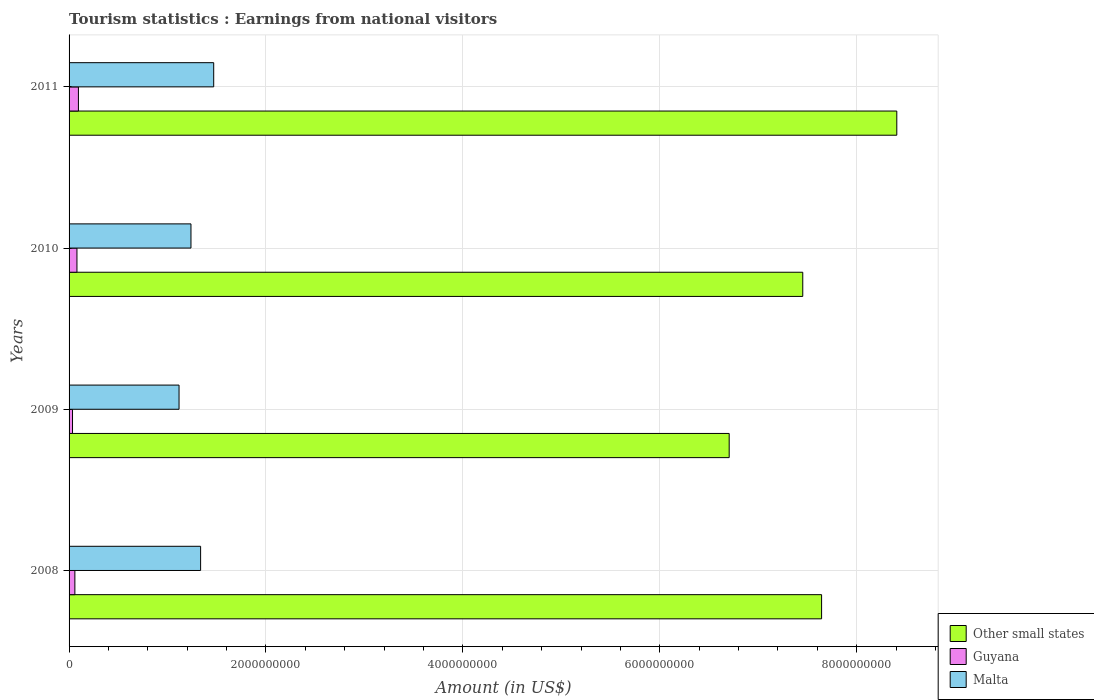How many different coloured bars are there?
Ensure brevity in your answer.  3. How many groups of bars are there?
Your answer should be very brief. 4. In how many cases, is the number of bars for a given year not equal to the number of legend labels?
Your answer should be very brief. 0. What is the earnings from national visitors in Other small states in 2009?
Give a very brief answer. 6.70e+09. Across all years, what is the maximum earnings from national visitors in Malta?
Your answer should be very brief. 1.47e+09. Across all years, what is the minimum earnings from national visitors in Malta?
Offer a very short reply. 1.12e+09. In which year was the earnings from national visitors in Malta minimum?
Keep it short and to the point. 2009. What is the total earnings from national visitors in Guyana in the graph?
Your answer should be very brief. 2.69e+08. What is the difference between the earnings from national visitors in Other small states in 2010 and that in 2011?
Ensure brevity in your answer.  -9.55e+08. What is the difference between the earnings from national visitors in Other small states in 2009 and the earnings from national visitors in Guyana in 2008?
Make the answer very short. 6.65e+09. What is the average earnings from national visitors in Malta per year?
Make the answer very short. 1.29e+09. In the year 2009, what is the difference between the earnings from national visitors in Guyana and earnings from national visitors in Malta?
Offer a very short reply. -1.08e+09. What is the ratio of the earnings from national visitors in Guyana in 2010 to that in 2011?
Ensure brevity in your answer.  0.84. Is the earnings from national visitors in Guyana in 2008 less than that in 2009?
Ensure brevity in your answer.  No. What is the difference between the highest and the second highest earnings from national visitors in Other small states?
Provide a short and direct response. 7.64e+08. What is the difference between the highest and the lowest earnings from national visitors in Malta?
Your answer should be compact. 3.52e+08. In how many years, is the earnings from national visitors in Other small states greater than the average earnings from national visitors in Other small states taken over all years?
Make the answer very short. 2. What does the 1st bar from the top in 2011 represents?
Ensure brevity in your answer.  Malta. What does the 2nd bar from the bottom in 2009 represents?
Offer a terse response. Guyana. What is the difference between two consecutive major ticks on the X-axis?
Ensure brevity in your answer.  2.00e+09. Where does the legend appear in the graph?
Keep it short and to the point. Bottom right. How are the legend labels stacked?
Provide a short and direct response. Vertical. What is the title of the graph?
Your response must be concise. Tourism statistics : Earnings from national visitors. What is the label or title of the Y-axis?
Ensure brevity in your answer.  Years. What is the Amount (in US$) in Other small states in 2008?
Give a very brief answer. 7.64e+09. What is the Amount (in US$) of Guyana in 2008?
Your answer should be very brief. 5.90e+07. What is the Amount (in US$) in Malta in 2008?
Ensure brevity in your answer.  1.34e+09. What is the Amount (in US$) in Other small states in 2009?
Offer a terse response. 6.70e+09. What is the Amount (in US$) in Guyana in 2009?
Offer a terse response. 3.50e+07. What is the Amount (in US$) in Malta in 2009?
Make the answer very short. 1.12e+09. What is the Amount (in US$) of Other small states in 2010?
Offer a very short reply. 7.45e+09. What is the Amount (in US$) in Guyana in 2010?
Provide a succinct answer. 8.00e+07. What is the Amount (in US$) of Malta in 2010?
Offer a terse response. 1.24e+09. What is the Amount (in US$) of Other small states in 2011?
Keep it short and to the point. 8.41e+09. What is the Amount (in US$) in Guyana in 2011?
Your answer should be very brief. 9.50e+07. What is the Amount (in US$) in Malta in 2011?
Your answer should be compact. 1.47e+09. Across all years, what is the maximum Amount (in US$) in Other small states?
Your response must be concise. 8.41e+09. Across all years, what is the maximum Amount (in US$) in Guyana?
Ensure brevity in your answer.  9.50e+07. Across all years, what is the maximum Amount (in US$) in Malta?
Keep it short and to the point. 1.47e+09. Across all years, what is the minimum Amount (in US$) in Other small states?
Your answer should be very brief. 6.70e+09. Across all years, what is the minimum Amount (in US$) of Guyana?
Your answer should be compact. 3.50e+07. Across all years, what is the minimum Amount (in US$) of Malta?
Ensure brevity in your answer.  1.12e+09. What is the total Amount (in US$) in Other small states in the graph?
Your response must be concise. 3.02e+1. What is the total Amount (in US$) in Guyana in the graph?
Your response must be concise. 2.69e+08. What is the total Amount (in US$) of Malta in the graph?
Make the answer very short. 5.16e+09. What is the difference between the Amount (in US$) in Other small states in 2008 and that in 2009?
Provide a succinct answer. 9.39e+08. What is the difference between the Amount (in US$) of Guyana in 2008 and that in 2009?
Offer a very short reply. 2.40e+07. What is the difference between the Amount (in US$) in Malta in 2008 and that in 2009?
Ensure brevity in your answer.  2.19e+08. What is the difference between the Amount (in US$) in Other small states in 2008 and that in 2010?
Provide a short and direct response. 1.91e+08. What is the difference between the Amount (in US$) of Guyana in 2008 and that in 2010?
Provide a succinct answer. -2.10e+07. What is the difference between the Amount (in US$) of Malta in 2008 and that in 2010?
Ensure brevity in your answer.  9.80e+07. What is the difference between the Amount (in US$) in Other small states in 2008 and that in 2011?
Your answer should be compact. -7.64e+08. What is the difference between the Amount (in US$) in Guyana in 2008 and that in 2011?
Your answer should be compact. -3.60e+07. What is the difference between the Amount (in US$) of Malta in 2008 and that in 2011?
Give a very brief answer. -1.33e+08. What is the difference between the Amount (in US$) in Other small states in 2009 and that in 2010?
Provide a succinct answer. -7.47e+08. What is the difference between the Amount (in US$) in Guyana in 2009 and that in 2010?
Ensure brevity in your answer.  -4.50e+07. What is the difference between the Amount (in US$) of Malta in 2009 and that in 2010?
Your answer should be compact. -1.21e+08. What is the difference between the Amount (in US$) in Other small states in 2009 and that in 2011?
Offer a very short reply. -1.70e+09. What is the difference between the Amount (in US$) of Guyana in 2009 and that in 2011?
Ensure brevity in your answer.  -6.00e+07. What is the difference between the Amount (in US$) of Malta in 2009 and that in 2011?
Your response must be concise. -3.52e+08. What is the difference between the Amount (in US$) of Other small states in 2010 and that in 2011?
Offer a very short reply. -9.55e+08. What is the difference between the Amount (in US$) of Guyana in 2010 and that in 2011?
Your answer should be very brief. -1.50e+07. What is the difference between the Amount (in US$) of Malta in 2010 and that in 2011?
Keep it short and to the point. -2.31e+08. What is the difference between the Amount (in US$) of Other small states in 2008 and the Amount (in US$) of Guyana in 2009?
Ensure brevity in your answer.  7.61e+09. What is the difference between the Amount (in US$) in Other small states in 2008 and the Amount (in US$) in Malta in 2009?
Give a very brief answer. 6.53e+09. What is the difference between the Amount (in US$) of Guyana in 2008 and the Amount (in US$) of Malta in 2009?
Provide a succinct answer. -1.06e+09. What is the difference between the Amount (in US$) of Other small states in 2008 and the Amount (in US$) of Guyana in 2010?
Your answer should be compact. 7.56e+09. What is the difference between the Amount (in US$) in Other small states in 2008 and the Amount (in US$) in Malta in 2010?
Provide a short and direct response. 6.41e+09. What is the difference between the Amount (in US$) in Guyana in 2008 and the Amount (in US$) in Malta in 2010?
Make the answer very short. -1.18e+09. What is the difference between the Amount (in US$) in Other small states in 2008 and the Amount (in US$) in Guyana in 2011?
Your answer should be very brief. 7.55e+09. What is the difference between the Amount (in US$) of Other small states in 2008 and the Amount (in US$) of Malta in 2011?
Give a very brief answer. 6.17e+09. What is the difference between the Amount (in US$) of Guyana in 2008 and the Amount (in US$) of Malta in 2011?
Provide a short and direct response. -1.41e+09. What is the difference between the Amount (in US$) in Other small states in 2009 and the Amount (in US$) in Guyana in 2010?
Ensure brevity in your answer.  6.62e+09. What is the difference between the Amount (in US$) in Other small states in 2009 and the Amount (in US$) in Malta in 2010?
Keep it short and to the point. 5.47e+09. What is the difference between the Amount (in US$) in Guyana in 2009 and the Amount (in US$) in Malta in 2010?
Your answer should be very brief. -1.20e+09. What is the difference between the Amount (in US$) in Other small states in 2009 and the Amount (in US$) in Guyana in 2011?
Your answer should be very brief. 6.61e+09. What is the difference between the Amount (in US$) of Other small states in 2009 and the Amount (in US$) of Malta in 2011?
Make the answer very short. 5.24e+09. What is the difference between the Amount (in US$) in Guyana in 2009 and the Amount (in US$) in Malta in 2011?
Make the answer very short. -1.43e+09. What is the difference between the Amount (in US$) of Other small states in 2010 and the Amount (in US$) of Guyana in 2011?
Your response must be concise. 7.36e+09. What is the difference between the Amount (in US$) in Other small states in 2010 and the Amount (in US$) in Malta in 2011?
Your answer should be very brief. 5.98e+09. What is the difference between the Amount (in US$) of Guyana in 2010 and the Amount (in US$) of Malta in 2011?
Your answer should be compact. -1.39e+09. What is the average Amount (in US$) in Other small states per year?
Give a very brief answer. 7.55e+09. What is the average Amount (in US$) in Guyana per year?
Give a very brief answer. 6.72e+07. What is the average Amount (in US$) of Malta per year?
Keep it short and to the point. 1.29e+09. In the year 2008, what is the difference between the Amount (in US$) of Other small states and Amount (in US$) of Guyana?
Make the answer very short. 7.58e+09. In the year 2008, what is the difference between the Amount (in US$) in Other small states and Amount (in US$) in Malta?
Give a very brief answer. 6.31e+09. In the year 2008, what is the difference between the Amount (in US$) in Guyana and Amount (in US$) in Malta?
Provide a succinct answer. -1.28e+09. In the year 2009, what is the difference between the Amount (in US$) in Other small states and Amount (in US$) in Guyana?
Offer a terse response. 6.67e+09. In the year 2009, what is the difference between the Amount (in US$) in Other small states and Amount (in US$) in Malta?
Offer a terse response. 5.59e+09. In the year 2009, what is the difference between the Amount (in US$) in Guyana and Amount (in US$) in Malta?
Your response must be concise. -1.08e+09. In the year 2010, what is the difference between the Amount (in US$) in Other small states and Amount (in US$) in Guyana?
Your answer should be very brief. 7.37e+09. In the year 2010, what is the difference between the Amount (in US$) of Other small states and Amount (in US$) of Malta?
Provide a short and direct response. 6.21e+09. In the year 2010, what is the difference between the Amount (in US$) of Guyana and Amount (in US$) of Malta?
Your answer should be very brief. -1.16e+09. In the year 2011, what is the difference between the Amount (in US$) of Other small states and Amount (in US$) of Guyana?
Give a very brief answer. 8.31e+09. In the year 2011, what is the difference between the Amount (in US$) in Other small states and Amount (in US$) in Malta?
Keep it short and to the point. 6.94e+09. In the year 2011, what is the difference between the Amount (in US$) of Guyana and Amount (in US$) of Malta?
Make the answer very short. -1.37e+09. What is the ratio of the Amount (in US$) of Other small states in 2008 to that in 2009?
Your answer should be compact. 1.14. What is the ratio of the Amount (in US$) in Guyana in 2008 to that in 2009?
Make the answer very short. 1.69. What is the ratio of the Amount (in US$) of Malta in 2008 to that in 2009?
Your answer should be compact. 1.2. What is the ratio of the Amount (in US$) of Other small states in 2008 to that in 2010?
Your response must be concise. 1.03. What is the ratio of the Amount (in US$) of Guyana in 2008 to that in 2010?
Your response must be concise. 0.74. What is the ratio of the Amount (in US$) in Malta in 2008 to that in 2010?
Keep it short and to the point. 1.08. What is the ratio of the Amount (in US$) of Other small states in 2008 to that in 2011?
Your answer should be compact. 0.91. What is the ratio of the Amount (in US$) in Guyana in 2008 to that in 2011?
Offer a terse response. 0.62. What is the ratio of the Amount (in US$) in Malta in 2008 to that in 2011?
Your answer should be very brief. 0.91. What is the ratio of the Amount (in US$) of Other small states in 2009 to that in 2010?
Your answer should be very brief. 0.9. What is the ratio of the Amount (in US$) in Guyana in 2009 to that in 2010?
Offer a terse response. 0.44. What is the ratio of the Amount (in US$) of Malta in 2009 to that in 2010?
Your answer should be very brief. 0.9. What is the ratio of the Amount (in US$) of Other small states in 2009 to that in 2011?
Ensure brevity in your answer.  0.8. What is the ratio of the Amount (in US$) in Guyana in 2009 to that in 2011?
Make the answer very short. 0.37. What is the ratio of the Amount (in US$) in Malta in 2009 to that in 2011?
Make the answer very short. 0.76. What is the ratio of the Amount (in US$) in Other small states in 2010 to that in 2011?
Your answer should be very brief. 0.89. What is the ratio of the Amount (in US$) of Guyana in 2010 to that in 2011?
Give a very brief answer. 0.84. What is the ratio of the Amount (in US$) of Malta in 2010 to that in 2011?
Keep it short and to the point. 0.84. What is the difference between the highest and the second highest Amount (in US$) of Other small states?
Offer a very short reply. 7.64e+08. What is the difference between the highest and the second highest Amount (in US$) in Guyana?
Ensure brevity in your answer.  1.50e+07. What is the difference between the highest and the second highest Amount (in US$) in Malta?
Your response must be concise. 1.33e+08. What is the difference between the highest and the lowest Amount (in US$) in Other small states?
Provide a short and direct response. 1.70e+09. What is the difference between the highest and the lowest Amount (in US$) in Guyana?
Give a very brief answer. 6.00e+07. What is the difference between the highest and the lowest Amount (in US$) in Malta?
Your response must be concise. 3.52e+08. 